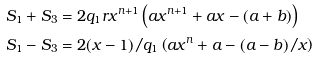<formula> <loc_0><loc_0><loc_500><loc_500>S _ { 1 } + S _ { 3 } & = 2 q _ { 1 } r x ^ { n + 1 } \left ( a x ^ { n + 1 } + a x - ( a + b ) \right ) \\ S _ { 1 } - S _ { 3 } & = 2 ( x - 1 ) / q _ { 1 } \left ( a x ^ { n } + a - ( a - b ) / x \right )</formula> 